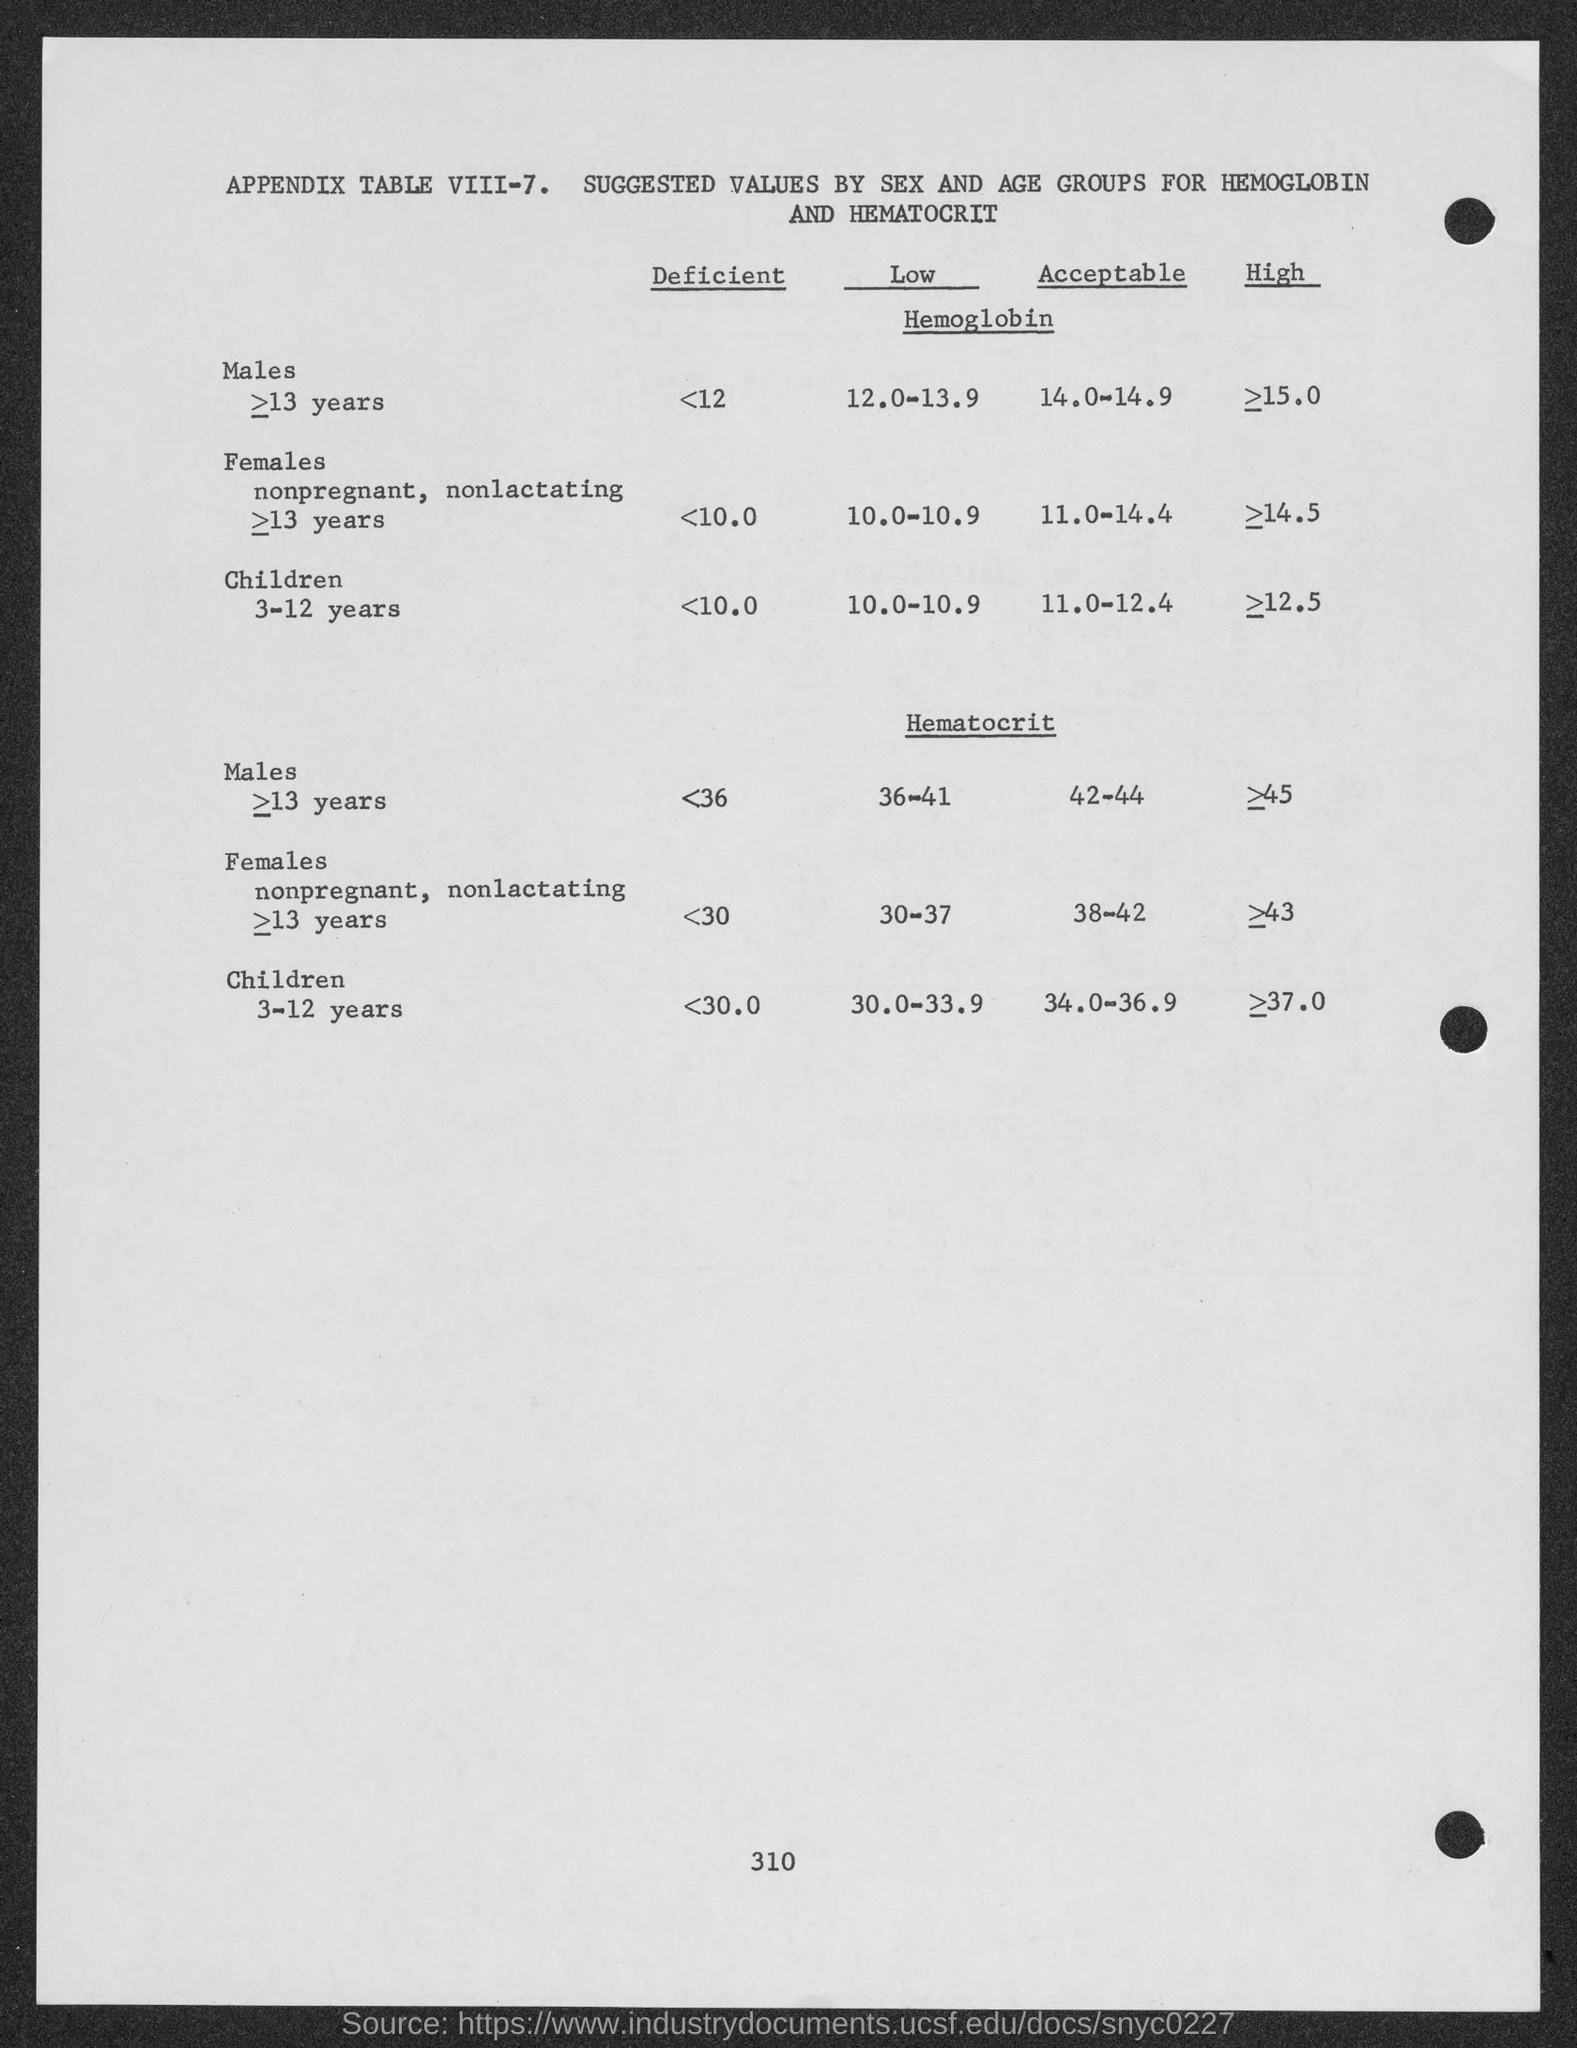Give some essential details in this illustration. It is estimated that a significant number of males have a deficiency in hemoglobin, with those having a hemoglobin level less than 12 grams per deciliter. It is estimated that a significant number of females have low levels of hemoglobin, with a deficiency threshold of less than 10.0. Approximately 10% of children have low levels of hemoglobin. The heading of the table is "Appendix Table VIII-7. Suggested values by sex and age groups for hemoglobin and hematocrit. 